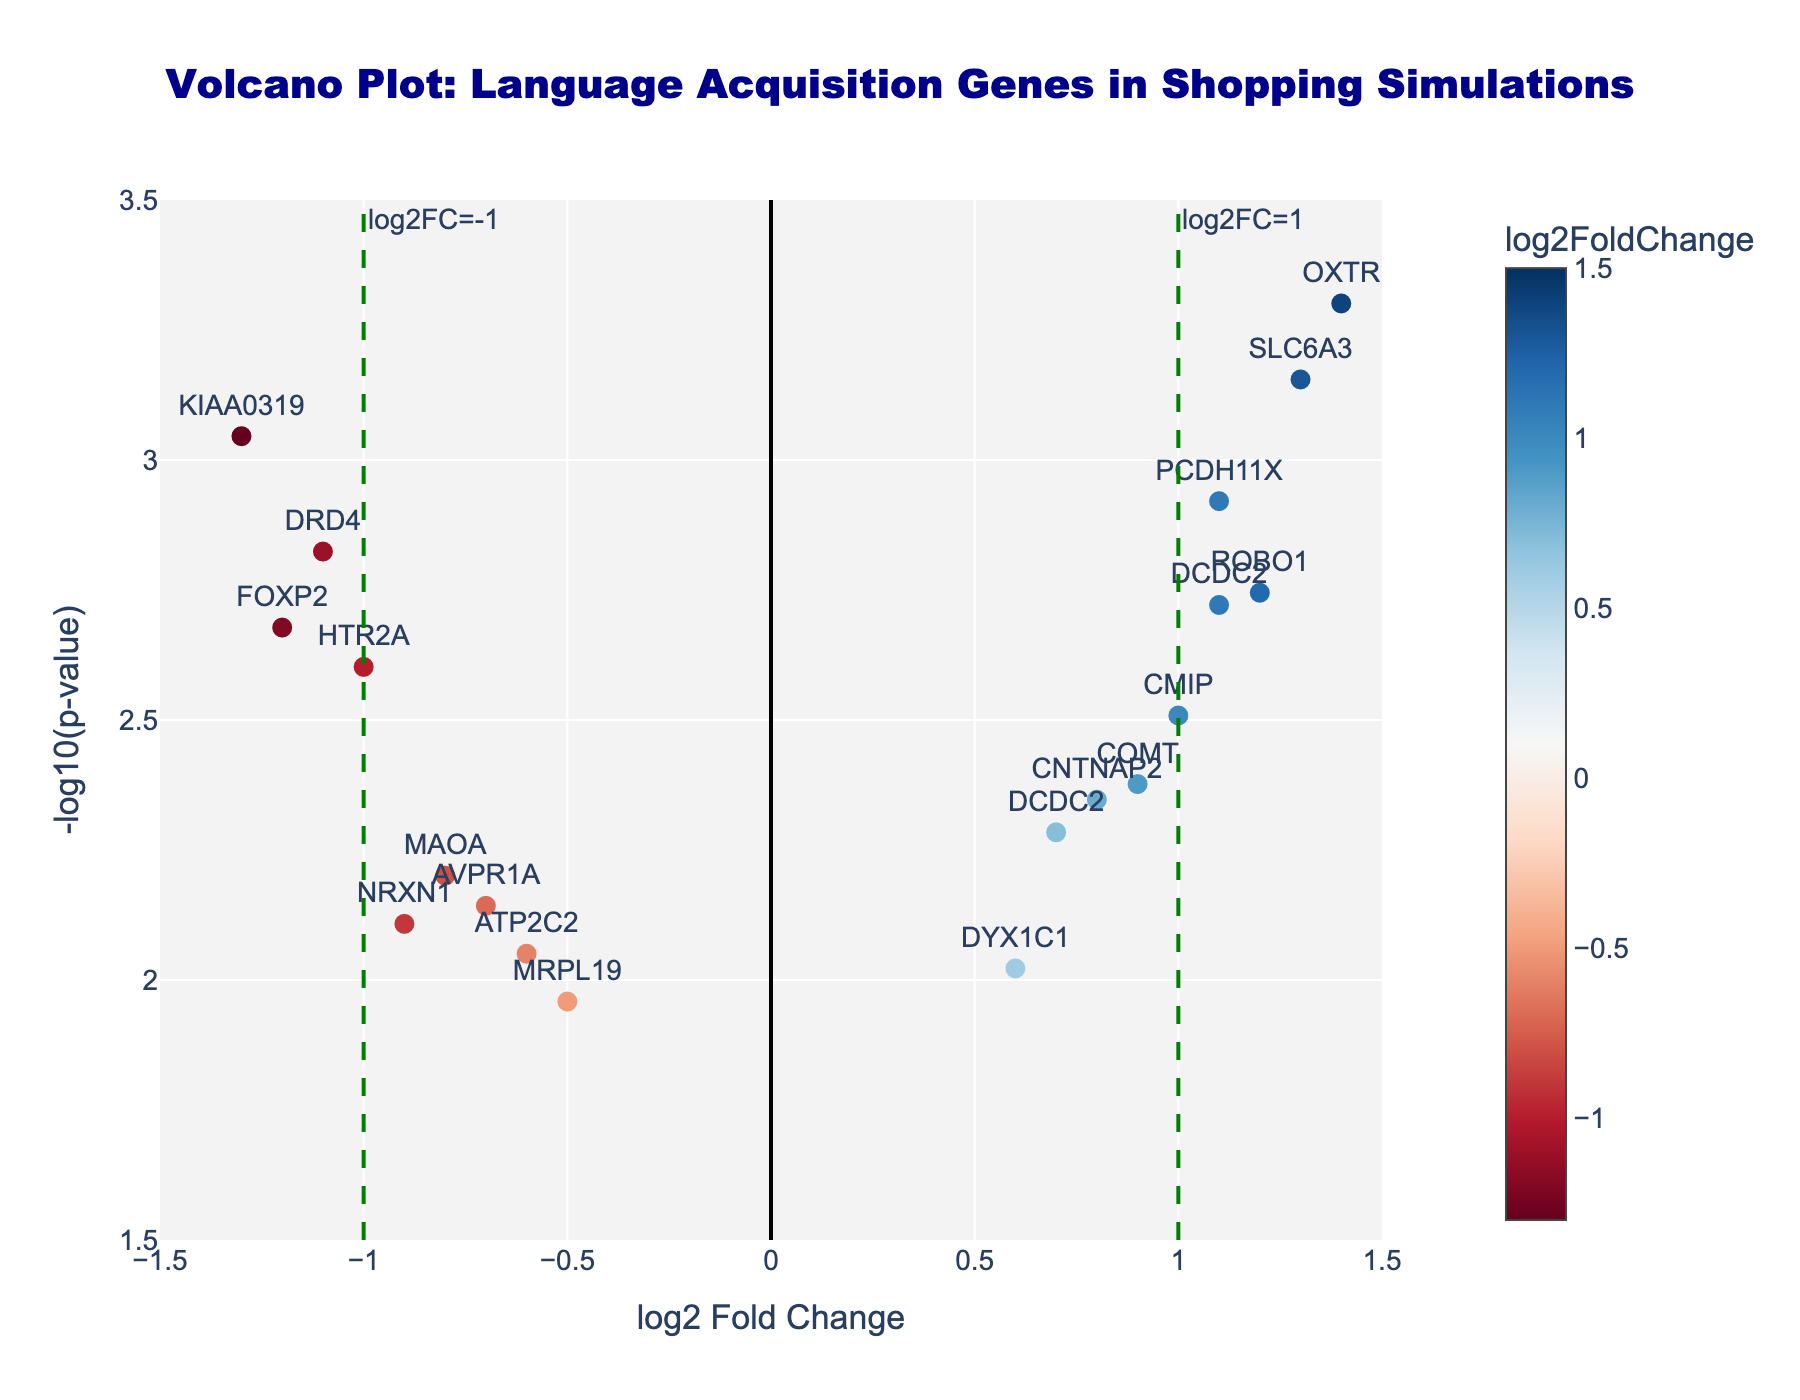What is the title of the plot? The title of the plot is written at the top and centered. It reads, "Volcano Plot: Language Acquisition Genes in Shopping Simulations."
Answer: Volcano Plot: Language Acquisition Genes in Shopping Simulations How many genes have a log2 fold change greater than 1? From the plot, the points right and beyond the vertical line at log2FC=1 are counted. The genes ROBO1, SLC6A3, and OXTR all have a log2FC greater than 1.
Answer: 3 Which gene has the largest negative log2 fold change? The most leftward point on the plot represents the gene with the largest negative log2 fold change. The gene KIAA0319 at log2FC=-1.3 has the largest negative change.
Answer: KIAA0319 What is the y-axis label of the plot? The y-axis label is written next to the y-axis on the left side of the plot, labeled as "-log10(p-value)."
Answer: -log10(p-value) Is the gene SLC6A3 statistically significant, considering the usual cutoff for p-value is 0.05? To be significant, the -log10(p-value) must be above the dashed red line at y=-log10(0.05). SLC6A3 is above the line, making it statistically significant.
Answer: Yes Which gene has the smallest p-value among those with a positive log2 fold change? The smallest p-value corresponds to the highest -log10(p-value). Among the points with positive fold changes, BDNF has the highest -log10(p-value).
Answer: BDNF Compare the log2 fold changes of FOXP2 and ROBO1. Which is greater? By looking at the x-axis positions of FOXP2 and ROBO1 points, we see that ROBO1's log2FC (1.2) is greater than that of FOXP2 (-1.2).
Answer: ROBO1 What is the log2 fold change for the gene CMIP? The log2 fold change is found on the x-axis for the specified gene text "CMIP". The x-axis position for CMIP shows a log2FC of 1.0.
Answer: 1.0 Which two points have the same log2 fold change but different p-values and what are they? By observing the plot, gene DCDC2 appears twice with the same log2FC of 1.1 but different y-axis positions for -log10(p-value).
Answer: DCDC2 Name one gene with a significant negative log2 fold change. A gene is significant if its -log10(p-value) is above the red dashed line, and it has a negative log2FC. The gene FOXP2 satisfies both conditions.
Answer: FOXP2 